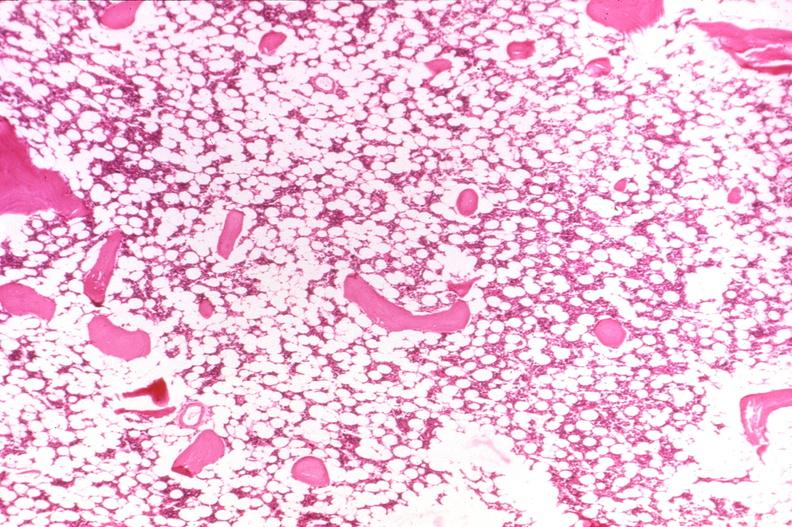what is present?
Answer the question using a single word or phrase. Joints 